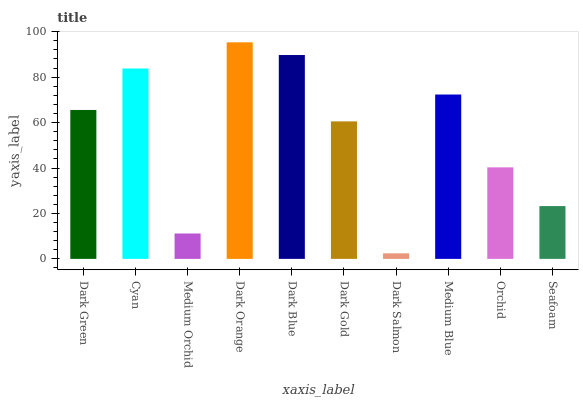Is Dark Salmon the minimum?
Answer yes or no. Yes. Is Dark Orange the maximum?
Answer yes or no. Yes. Is Cyan the minimum?
Answer yes or no. No. Is Cyan the maximum?
Answer yes or no. No. Is Cyan greater than Dark Green?
Answer yes or no. Yes. Is Dark Green less than Cyan?
Answer yes or no. Yes. Is Dark Green greater than Cyan?
Answer yes or no. No. Is Cyan less than Dark Green?
Answer yes or no. No. Is Dark Green the high median?
Answer yes or no. Yes. Is Dark Gold the low median?
Answer yes or no. Yes. Is Medium Orchid the high median?
Answer yes or no. No. Is Medium Orchid the low median?
Answer yes or no. No. 